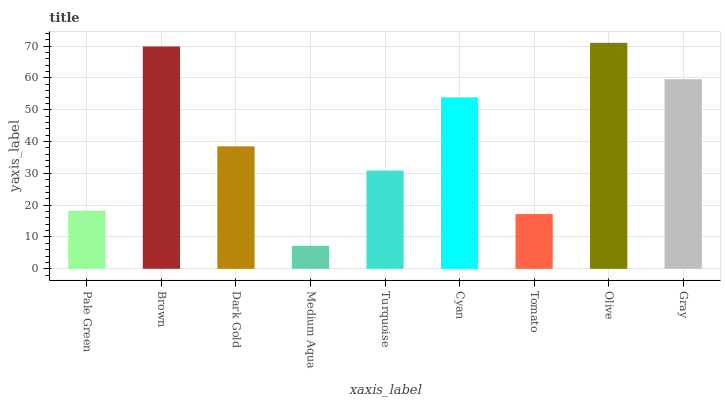Is Brown the minimum?
Answer yes or no. No. Is Brown the maximum?
Answer yes or no. No. Is Brown greater than Pale Green?
Answer yes or no. Yes. Is Pale Green less than Brown?
Answer yes or no. Yes. Is Pale Green greater than Brown?
Answer yes or no. No. Is Brown less than Pale Green?
Answer yes or no. No. Is Dark Gold the high median?
Answer yes or no. Yes. Is Dark Gold the low median?
Answer yes or no. Yes. Is Tomato the high median?
Answer yes or no. No. Is Cyan the low median?
Answer yes or no. No. 